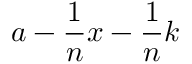Convert formula to latex. <formula><loc_0><loc_0><loc_500><loc_500>a - { \frac { 1 } { n } } x - { \frac { 1 } { n } } k</formula> 